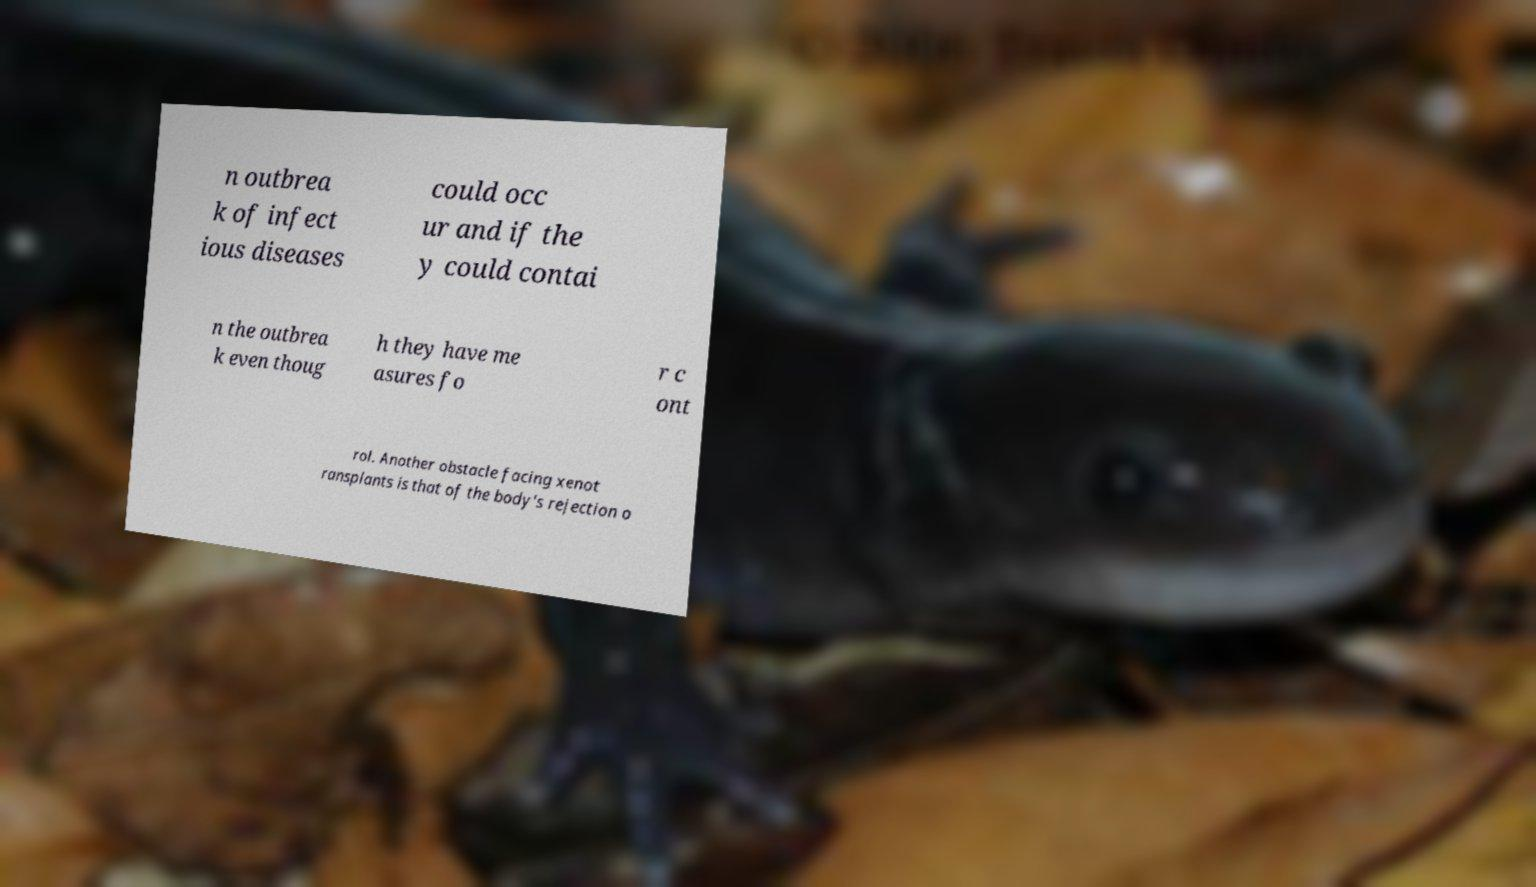Could you assist in decoding the text presented in this image and type it out clearly? n outbrea k of infect ious diseases could occ ur and if the y could contai n the outbrea k even thoug h they have me asures fo r c ont rol. Another obstacle facing xenot ransplants is that of the body's rejection o 